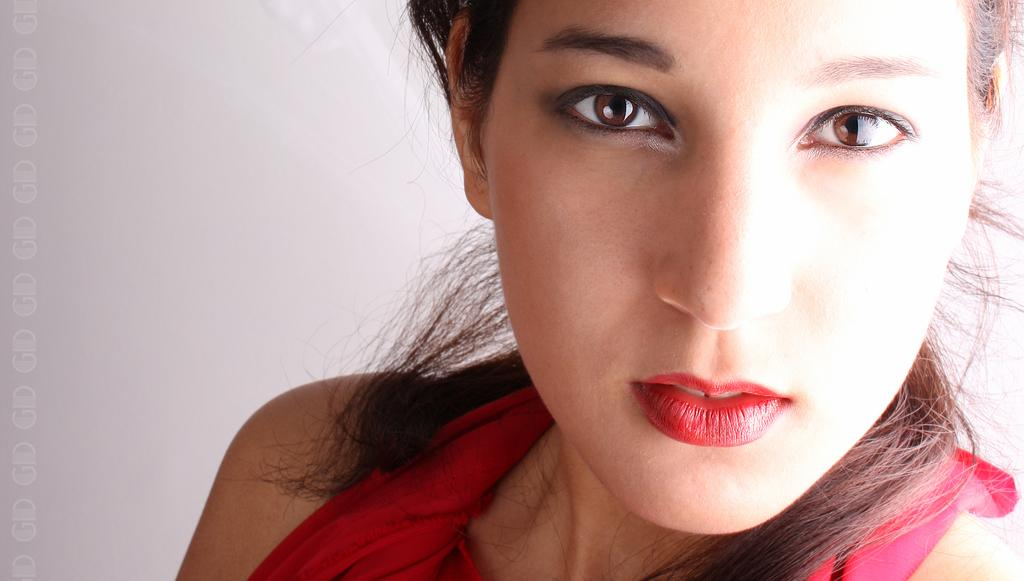What is the color of the background in the image? The background of the image is gray. Where is the girl located in the image? The girl is on the right side of the image. What is the girl wearing in the image? The girl is wearing a red dress and red lipstick. Can you see an airplane in the image? No, there is no airplane present in the image. What type of brake is visible on the girl's dress? There is no brake visible on the girl's dress; it is a dress, not a vehicle. 